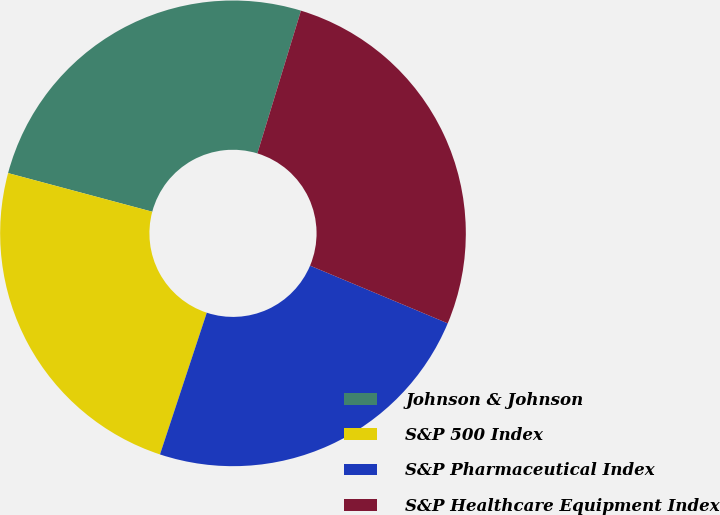Convert chart. <chart><loc_0><loc_0><loc_500><loc_500><pie_chart><fcel>Johnson & Johnson<fcel>S&P 500 Index<fcel>S&P Pharmaceutical Index<fcel>S&P Healthcare Equipment Index<nl><fcel>25.55%<fcel>24.09%<fcel>23.76%<fcel>26.6%<nl></chart> 